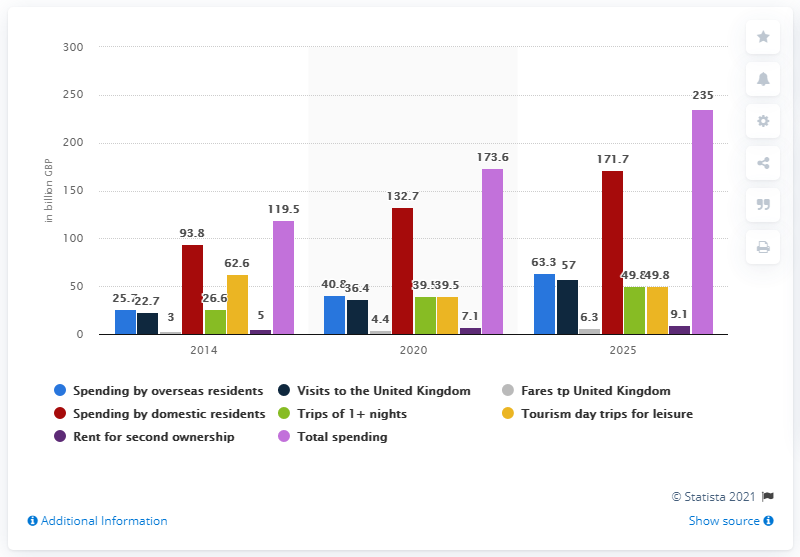Can you describe the trend in the spending by overseas residents from 2014 compared to 2020 based on the graph? The graph shows that spending by overseas residents in the UK increased from 93.8 billion GBP in 2014 to 119.5 billion GBP in 2020, highlighting a growing interest and investment by foreign visitors over these years. 